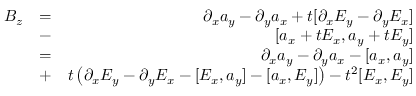Convert formula to latex. <formula><loc_0><loc_0><loc_500><loc_500>\begin{array} { r l r } { B _ { z } } & { = } & { \partial _ { x } a _ { y } - \partial _ { y } a _ { x } + t [ \partial _ { x } E _ { y } - \partial _ { y } E _ { x } ] } \\ & { - } & { [ a _ { x } + t E _ { x } , a _ { y } + t E _ { y } ] } \\ & { = } & { \partial _ { x } a _ { y } - \partial _ { y } a _ { x } - [ a _ { x } , a _ { y } ] } \\ & { + } & { t \left ( \partial _ { x } E _ { y } - \partial _ { y } E _ { x } - [ E _ { x } , a _ { y } ] - [ a _ { x } , E _ { y } ] \right ) - t ^ { 2 } [ E _ { x } , E _ { y } ] } \end{array}</formula> 